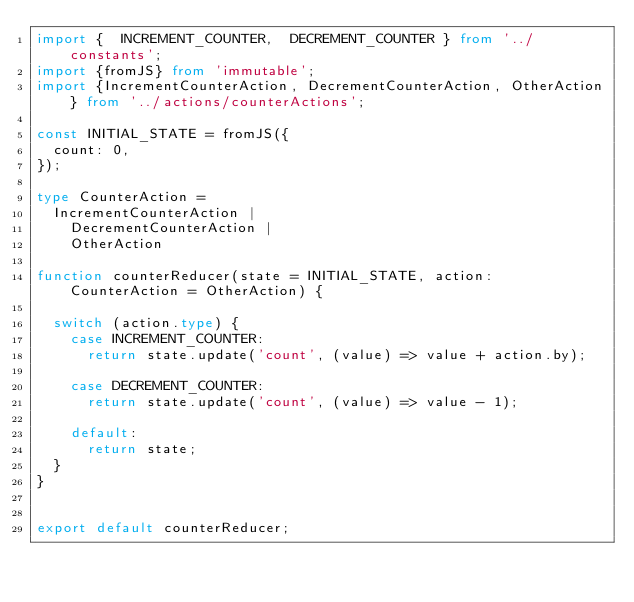Convert code to text. <code><loc_0><loc_0><loc_500><loc_500><_TypeScript_>import {  INCREMENT_COUNTER,  DECREMENT_COUNTER } from '../constants';
import {fromJS} from 'immutable';
import {IncrementCounterAction, DecrementCounterAction, OtherAction} from '../actions/counterActions';

const INITIAL_STATE = fromJS({
  count: 0,
});

type CounterAction =
  IncrementCounterAction |
    DecrementCounterAction |
    OtherAction

function counterReducer(state = INITIAL_STATE, action: CounterAction = OtherAction) {

  switch (action.type) {
    case INCREMENT_COUNTER:
      return state.update('count', (value) => value + action.by);

    case DECREMENT_COUNTER:
      return state.update('count', (value) => value - 1);

    default:
      return state;
  }
}


export default counterReducer;

</code> 